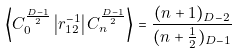Convert formula to latex. <formula><loc_0><loc_0><loc_500><loc_500>\left < C _ { 0 } ^ { \frac { D - 1 } { 2 } } \left | r _ { 1 2 } ^ { - 1 } \right | C _ { n } ^ { \frac { D - 1 } { 2 } } \right > = \frac { ( n + 1 ) _ { D - 2 } } { ( n + \frac { 1 } { 2 } ) _ { D - 1 } }</formula> 